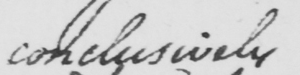Can you read and transcribe this handwriting? conclusively 